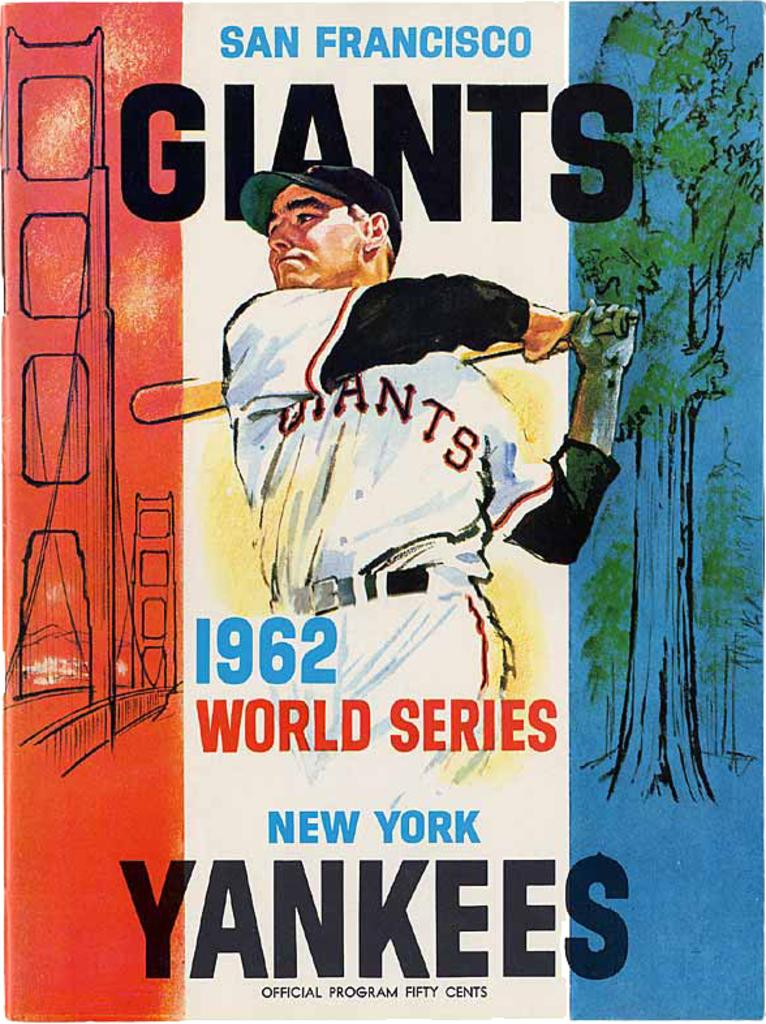What is the main subject in the image? There is a poster in the image. What can be seen in the center of the poster? There is a person in the center of the poster. What type of scenery is visible in the background of the poster? There are trees in the background of the poster. What type of information is provided at the top of the poster? There is text at the top of the poster. What type of information is provided at the bottom of the poster? There is text at the bottom of the poster. What type of tool is the woman using to cut the poster in the image? There is no woman present in the image, nor is there any tool being used to cut the poster. 